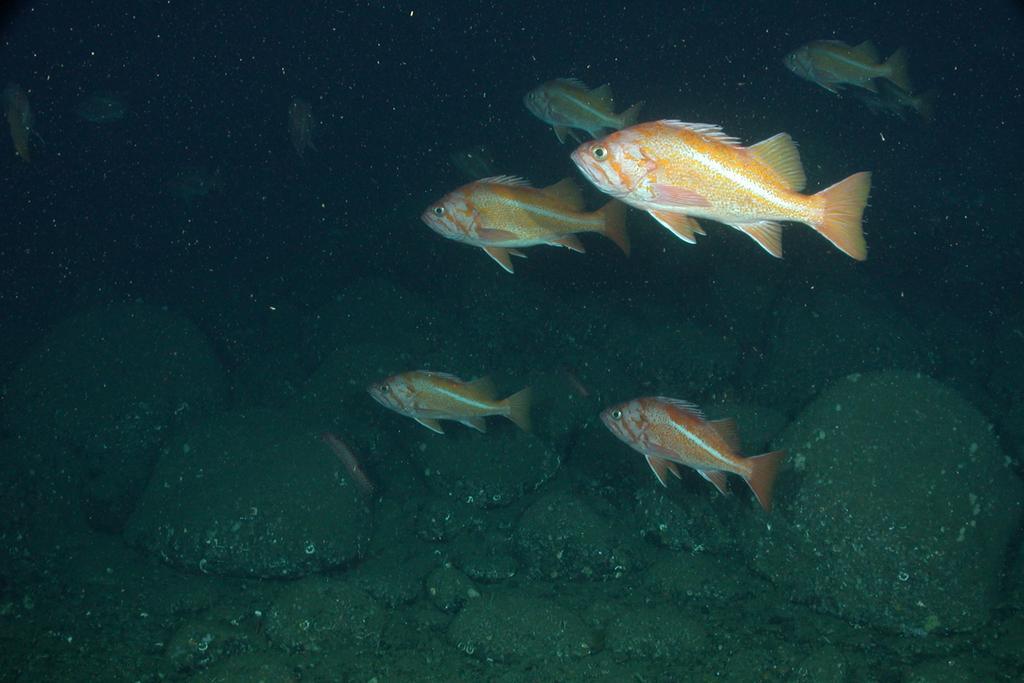How would you summarize this image in a sentence or two? In the center of the image we can see water and stones. In the water, we can see fishes, which are in orange and white color. 